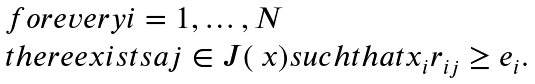<formula> <loc_0><loc_0><loc_500><loc_500>\begin{array} { l } f o r e v e r y i = 1 , \dots , N \\ t h e r e e x i s t s a j \in J ( \ x ) s u c h t h a t x _ { i } r _ { i j } \geq e _ { i } . \end{array}</formula> 